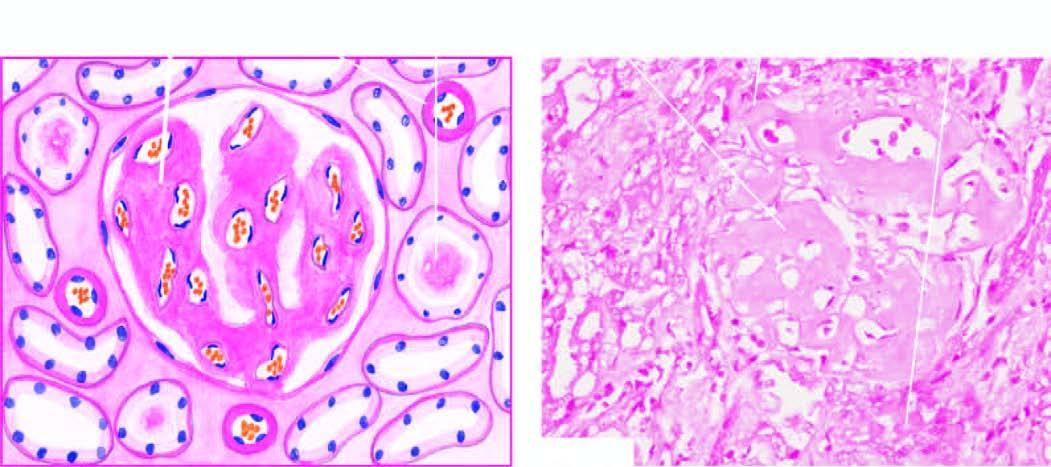does amyloid cast in the tubular lumina, and in the arterial wall producing luminal narrowing?
Answer the question using a single word or phrase. Yes 